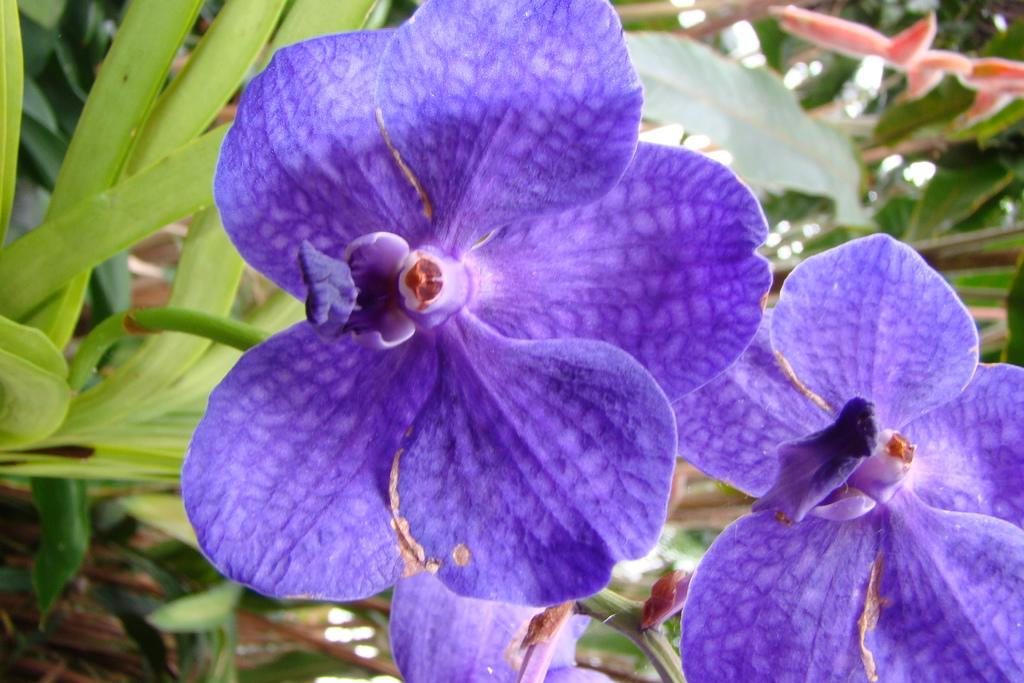What types of flowers are in the foreground of the image? There are two violet flowers in the foreground of the image. What can be inferred about the flowers' origin? The flowers belong to a plant. What else can be seen in the image besides the flowers? There are plants visible in the background of the image. What type of drink is being served in the image? There is no drink present in the image; it features two violet flowers and plants in the background. 